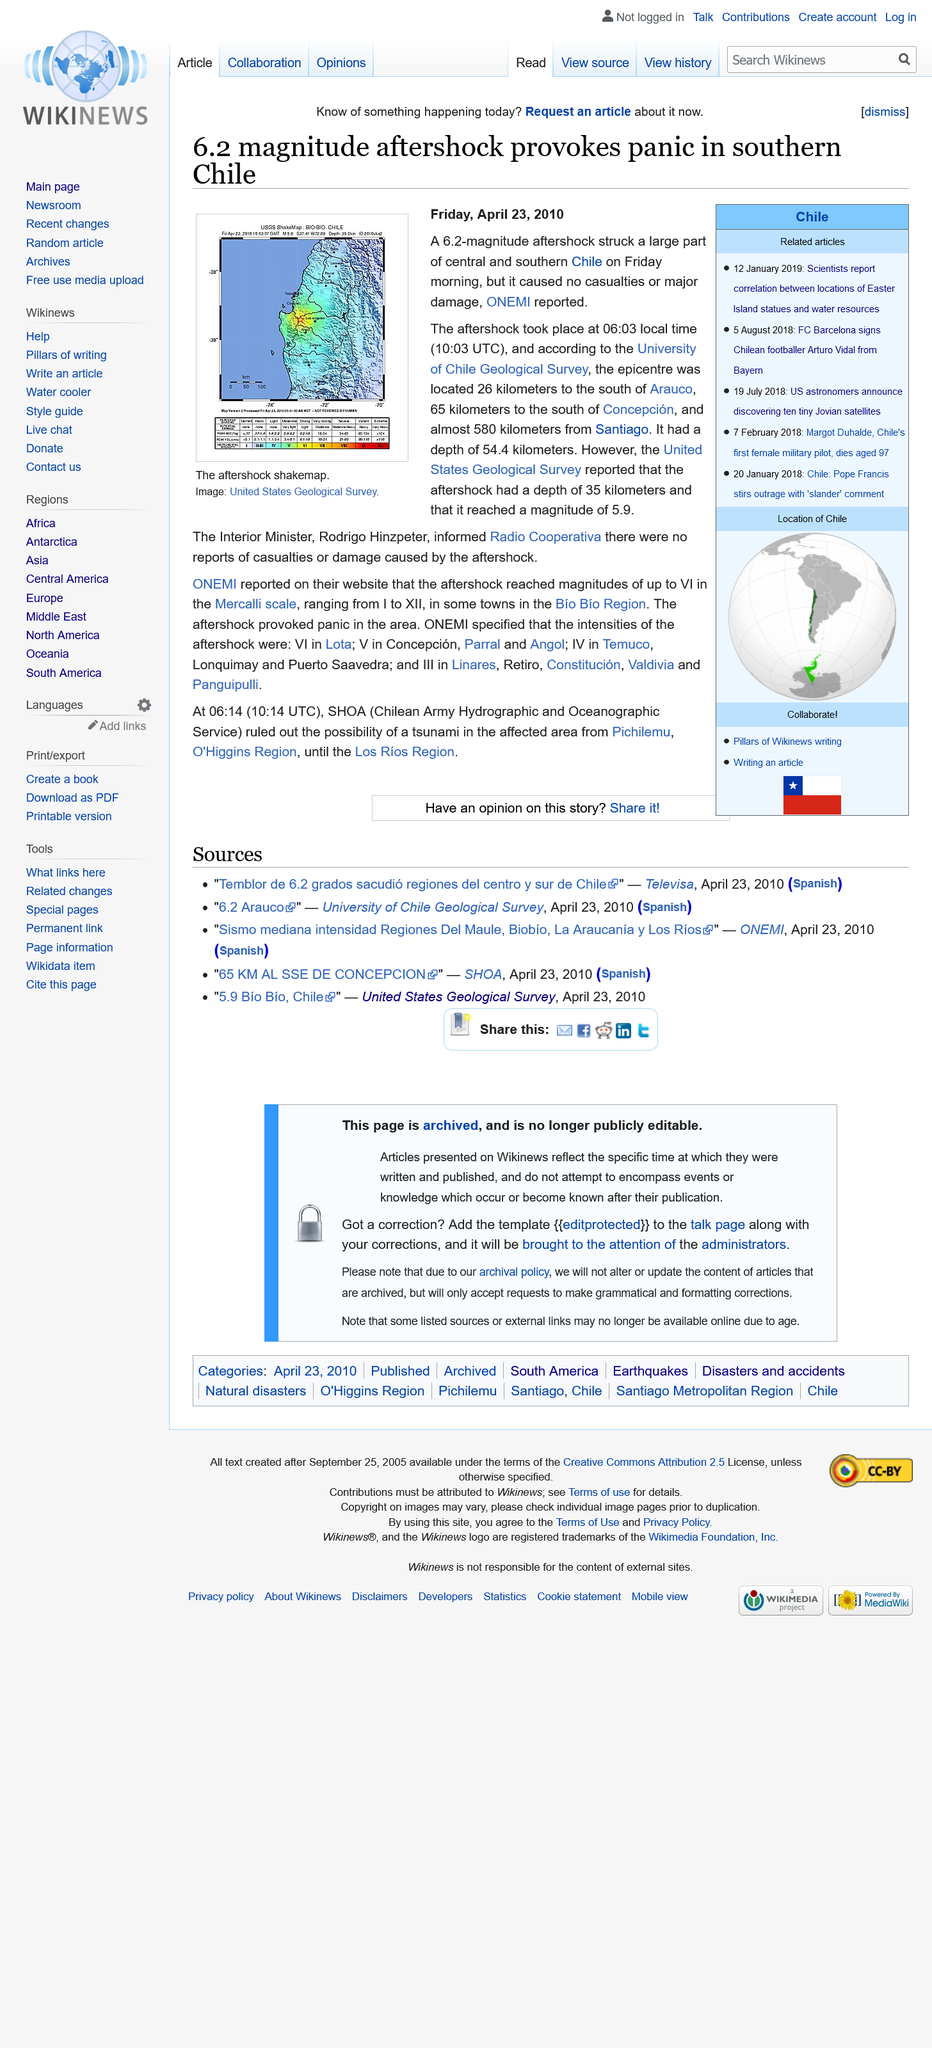Identify some key points in this picture. The aftershock that occurred was a significant distance away from Santiago. The report was published on April 23, 2010, in the format of DD/MM/YYYY. There were zero casualties reported. 